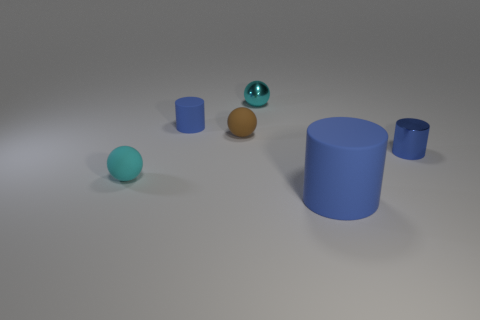What number of other objects are there of the same material as the small brown thing?
Offer a terse response. 3. There is a tiny cylinder right of the big blue rubber cylinder; does it have the same color as the small rubber object in front of the brown object?
Your response must be concise. No. Are any large blue objects visible?
Offer a very short reply. Yes. What material is the tiny thing that is the same color as the small matte cylinder?
Your answer should be compact. Metal. There is a blue rubber object that is behind the cyan thing in front of the cyan ball that is behind the cyan rubber object; how big is it?
Your response must be concise. Small. There is a small cyan matte thing; is it the same shape as the small blue thing on the right side of the brown rubber sphere?
Give a very brief answer. No. Are there any tiny rubber balls of the same color as the large rubber cylinder?
Ensure brevity in your answer.  No. What number of cubes are large matte objects or small brown matte objects?
Offer a very short reply. 0. Is there another cyan rubber object of the same shape as the big thing?
Give a very brief answer. No. What number of other things are there of the same color as the large object?
Offer a terse response. 2. 